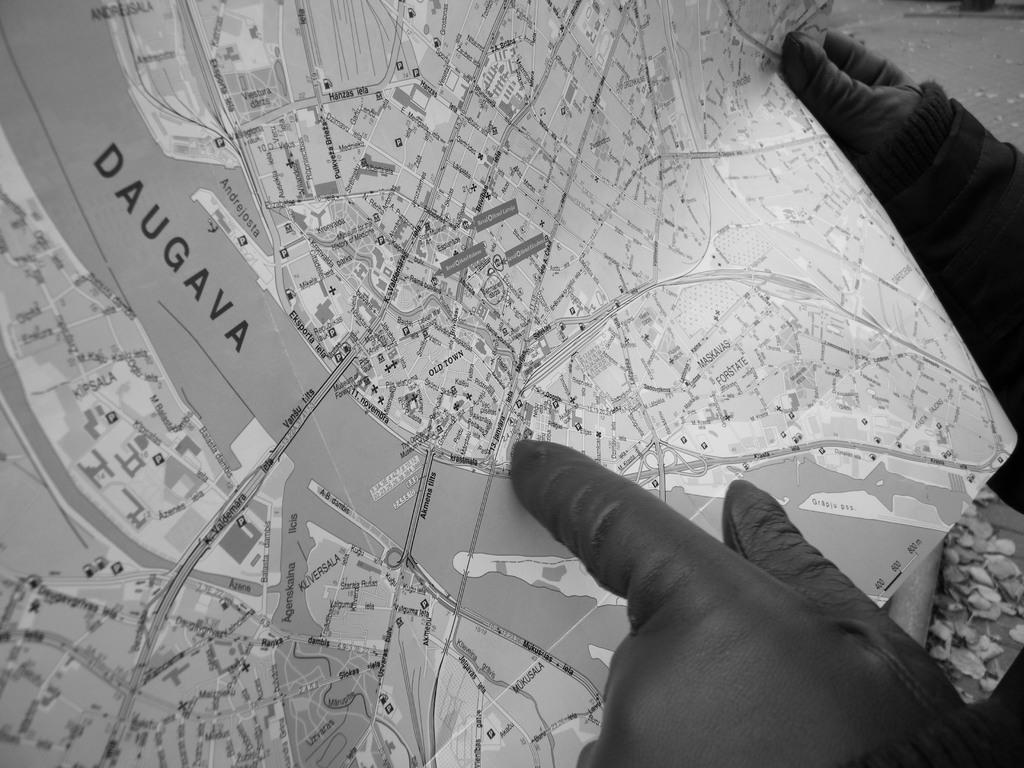What is the person in the image holding? The person is holding a paper. What is depicted on the paper? The paper contains a route map. Are there any other papers visible in the image? Yes, there are pieces of paper on the floor. What type of pear is shown in the caption of the image? There is no pear or caption present in the image. 